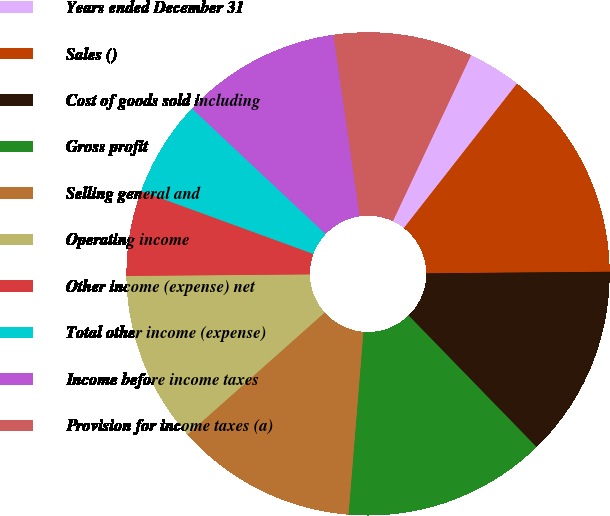Convert chart. <chart><loc_0><loc_0><loc_500><loc_500><pie_chart><fcel>Years ended December 31<fcel>Sales ()<fcel>Cost of goods sold including<fcel>Gross profit<fcel>Selling general and<fcel>Operating income<fcel>Other income (expense) net<fcel>Total other income (expense)<fcel>Income before income taxes<fcel>Provision for income taxes (a)<nl><fcel>3.57%<fcel>14.29%<fcel>12.86%<fcel>13.57%<fcel>12.14%<fcel>11.43%<fcel>5.71%<fcel>6.43%<fcel>10.71%<fcel>9.29%<nl></chart> 